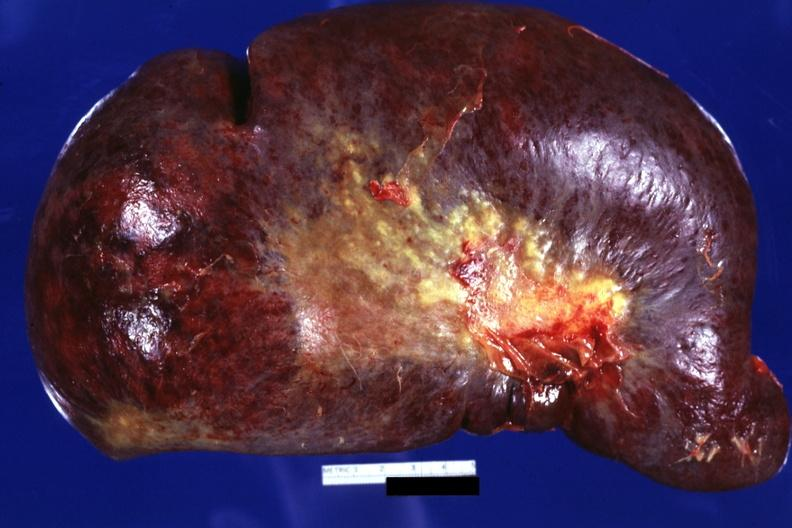what is present?
Answer the question using a single word or phrase. Hematologic 